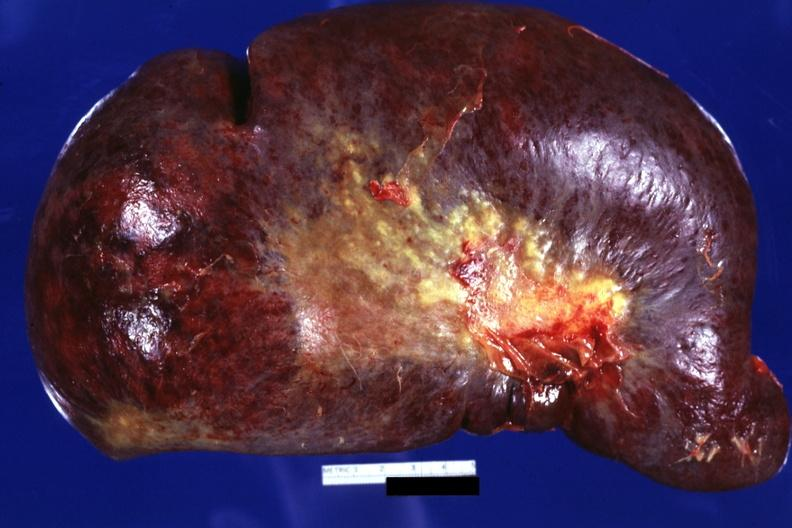what is present?
Answer the question using a single word or phrase. Hematologic 